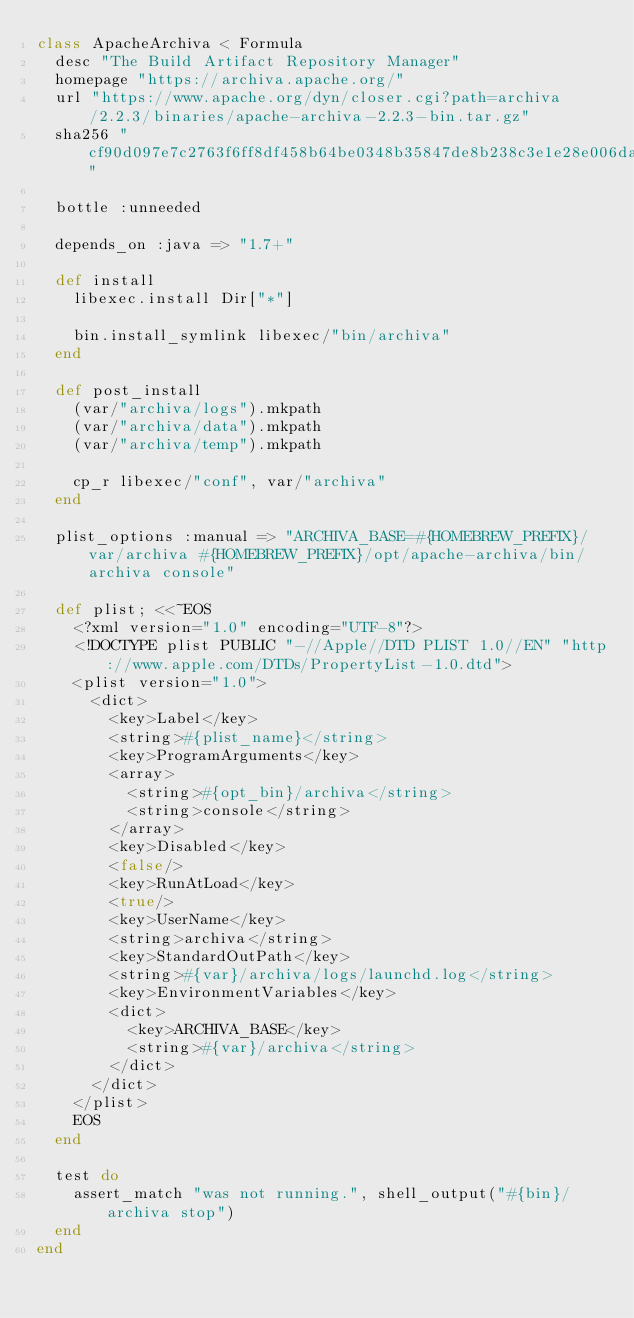<code> <loc_0><loc_0><loc_500><loc_500><_Ruby_>class ApacheArchiva < Formula
  desc "The Build Artifact Repository Manager"
  homepage "https://archiva.apache.org/"
  url "https://www.apache.org/dyn/closer.cgi?path=archiva/2.2.3/binaries/apache-archiva-2.2.3-bin.tar.gz"
  sha256 "cf90d097e7c2763f6ff8df458b64be0348b35847de8b238c3e1e28e006da8bad"

  bottle :unneeded

  depends_on :java => "1.7+"

  def install
    libexec.install Dir["*"]

    bin.install_symlink libexec/"bin/archiva"
  end

  def post_install
    (var/"archiva/logs").mkpath
    (var/"archiva/data").mkpath
    (var/"archiva/temp").mkpath

    cp_r libexec/"conf", var/"archiva"
  end

  plist_options :manual => "ARCHIVA_BASE=#{HOMEBREW_PREFIX}/var/archiva #{HOMEBREW_PREFIX}/opt/apache-archiva/bin/archiva console"

  def plist; <<~EOS
    <?xml version="1.0" encoding="UTF-8"?>
    <!DOCTYPE plist PUBLIC "-//Apple//DTD PLIST 1.0//EN" "http://www.apple.com/DTDs/PropertyList-1.0.dtd">
    <plist version="1.0">
      <dict>
        <key>Label</key>
        <string>#{plist_name}</string>
        <key>ProgramArguments</key>
        <array>
          <string>#{opt_bin}/archiva</string>
          <string>console</string>
        </array>
        <key>Disabled</key>
        <false/>
        <key>RunAtLoad</key>
        <true/>
        <key>UserName</key>
        <string>archiva</string>
        <key>StandardOutPath</key>
        <string>#{var}/archiva/logs/launchd.log</string>
        <key>EnvironmentVariables</key>
        <dict>
          <key>ARCHIVA_BASE</key>
          <string>#{var}/archiva</string>
        </dict>
      </dict>
    </plist>
    EOS
  end

  test do
    assert_match "was not running.", shell_output("#{bin}/archiva stop")
  end
end
</code> 